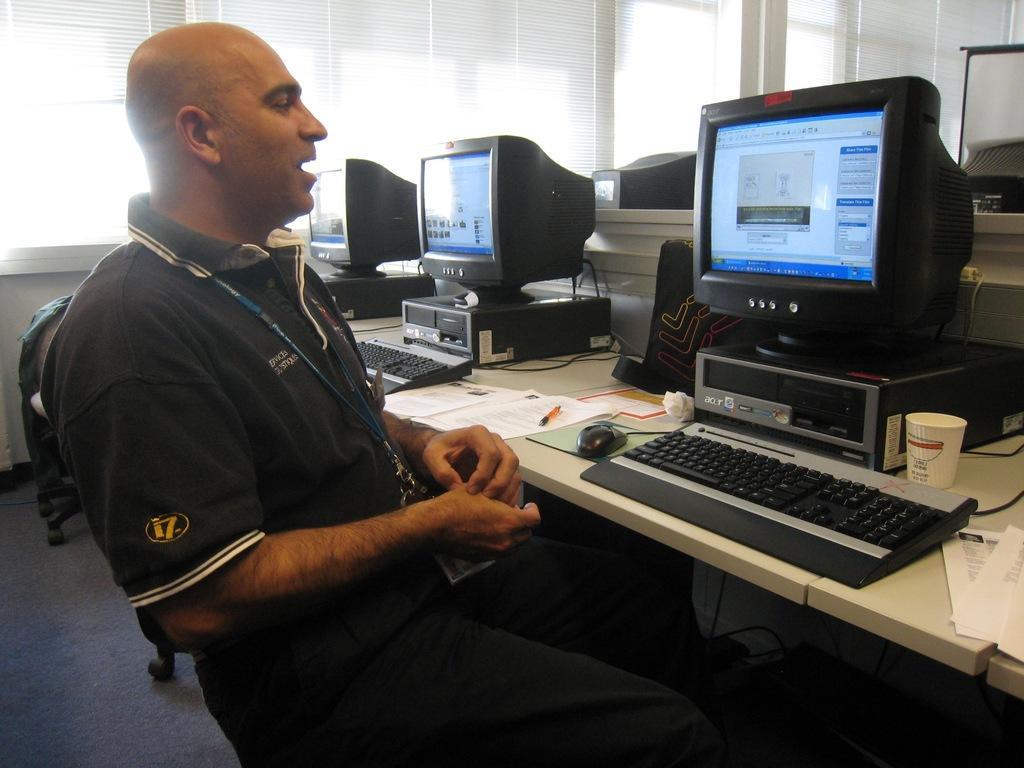Could you give a brief overview of what you see in this image? In this picture we can see a man sitting on a chair wearing id card. In Front of him there are monitors and keyboards and mouse on the table. This is a glass. These are papers. On the background we can see windows. this is a floor. 